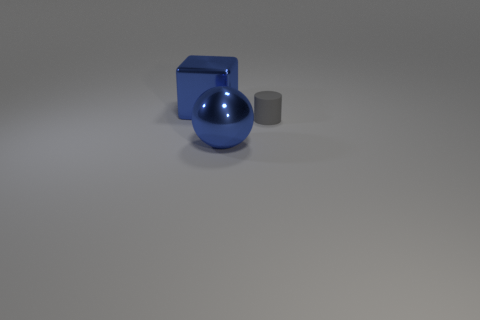Add 1 cyan objects. How many objects exist? 4 Subtract 1 cubes. How many cubes are left? 0 Subtract all cylinders. How many objects are left? 2 Subtract all red metal cubes. Subtract all blue objects. How many objects are left? 1 Add 1 blue shiny spheres. How many blue shiny spheres are left? 2 Add 3 gray cylinders. How many gray cylinders exist? 4 Subtract 0 brown cylinders. How many objects are left? 3 Subtract all cyan balls. Subtract all purple cubes. How many balls are left? 1 